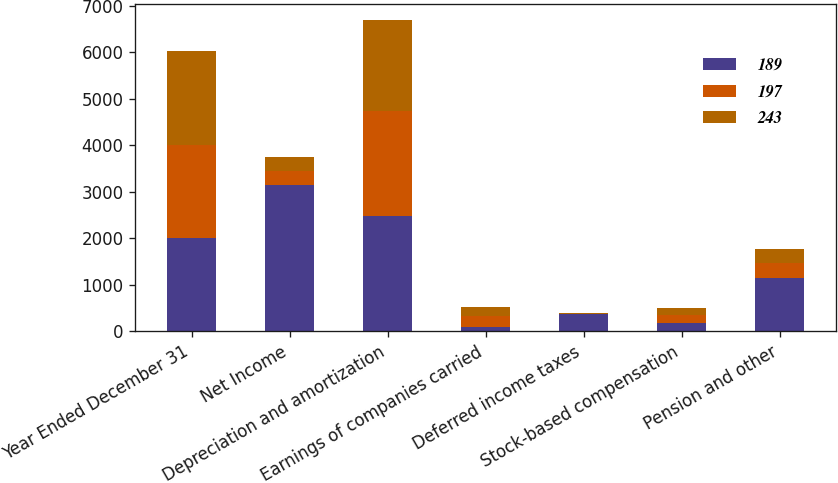<chart> <loc_0><loc_0><loc_500><loc_500><stacked_bar_chart><ecel><fcel>Year Ended December 31<fcel>Net Income<fcel>Depreciation and amortization<fcel>Earnings of companies carried<fcel>Deferred income taxes<fcel>Stock-based compensation<fcel>Pension and other<nl><fcel>189<fcel>2009<fcel>3142<fcel>2476<fcel>103<fcel>373<fcel>186<fcel>1149<nl><fcel>197<fcel>2008<fcel>300<fcel>2269<fcel>235<fcel>6<fcel>172<fcel>318<nl><fcel>243<fcel>2007<fcel>300<fcel>1954<fcel>183<fcel>22<fcel>136<fcel>294<nl></chart> 